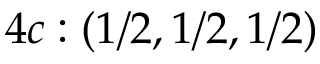Convert formula to latex. <formula><loc_0><loc_0><loc_500><loc_500>4 c \colon ( 1 / 2 , 1 / 2 , 1 / 2 )</formula> 